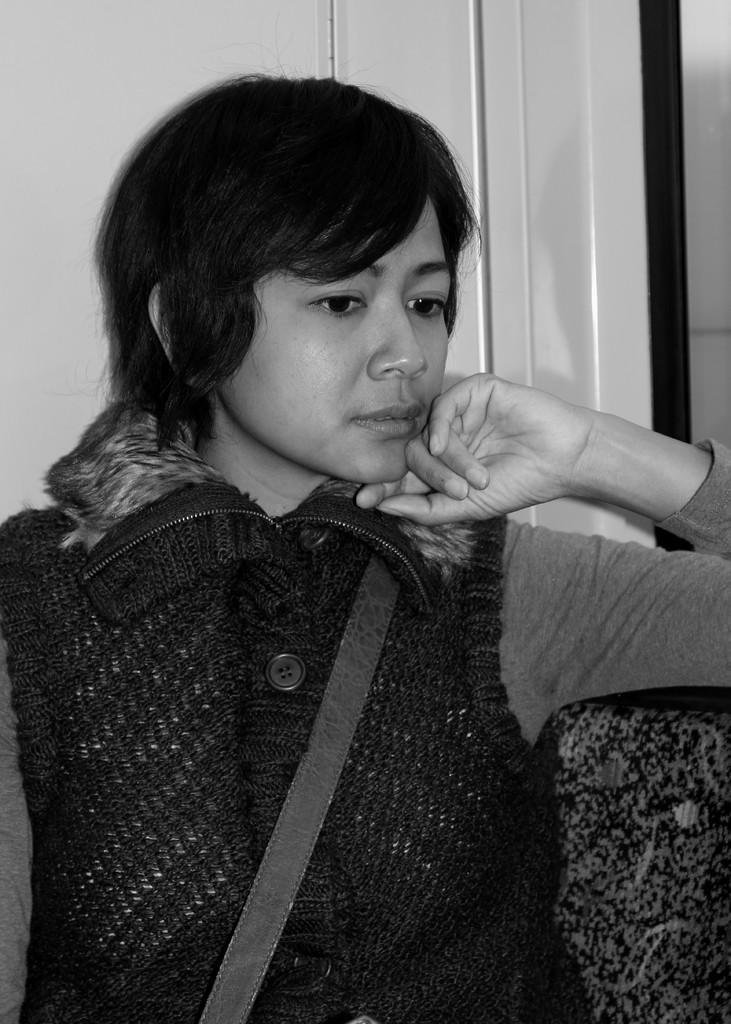Could you give a brief overview of what you see in this image? In this picture we can see a person sitting on the chair. A wall is visible in the background. 